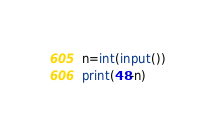<code> <loc_0><loc_0><loc_500><loc_500><_Python_>n=int(input())
print(48-n)
</code> 